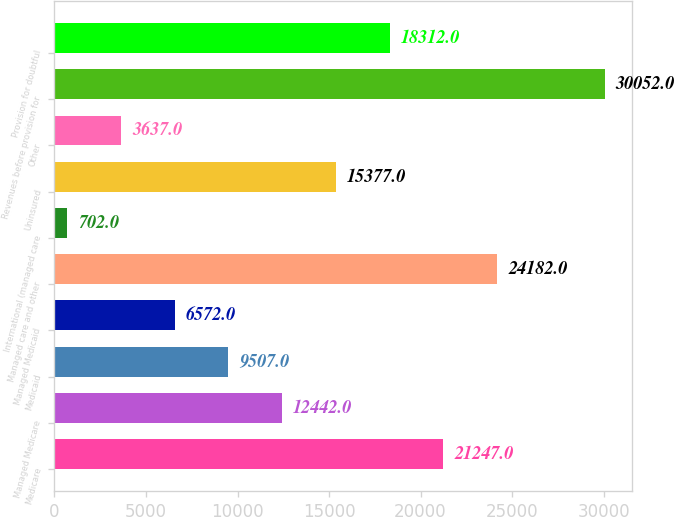Convert chart. <chart><loc_0><loc_0><loc_500><loc_500><bar_chart><fcel>Medicare<fcel>Managed Medicare<fcel>Medicaid<fcel>Managed Medicaid<fcel>Managed care and other<fcel>International (managed care<fcel>Uninsured<fcel>Other<fcel>Revenues before provision for<fcel>Provision for doubtful<nl><fcel>21247<fcel>12442<fcel>9507<fcel>6572<fcel>24182<fcel>702<fcel>15377<fcel>3637<fcel>30052<fcel>18312<nl></chart> 